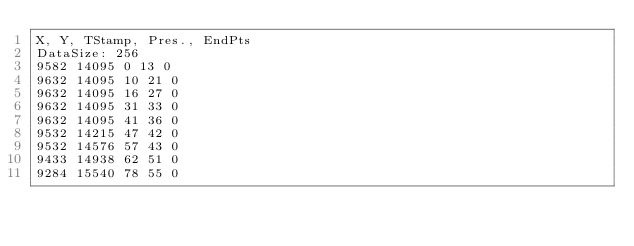<code> <loc_0><loc_0><loc_500><loc_500><_SML_>X, Y, TStamp, Pres., EndPts
DataSize: 256
9582 14095 0 13 0
9632 14095 10 21 0
9632 14095 16 27 0
9632 14095 31 33 0
9632 14095 41 36 0
9532 14215 47 42 0
9532 14576 57 43 0
9433 14938 62 51 0
9284 15540 78 55 0</code> 